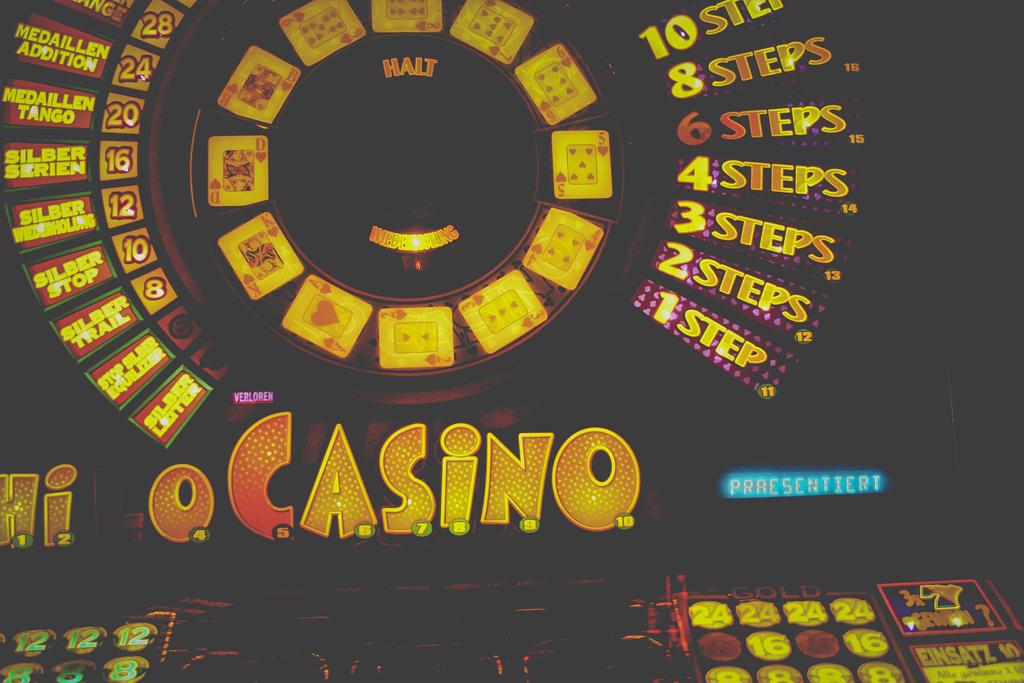How many steps are on the casino?
Make the answer very short. 10. What word is at the top of the center circle?
Provide a succinct answer. Halt. 